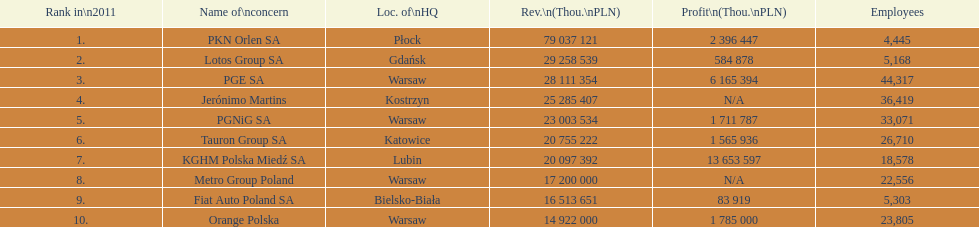Which organization had the highest number of workers? PGE SA. 